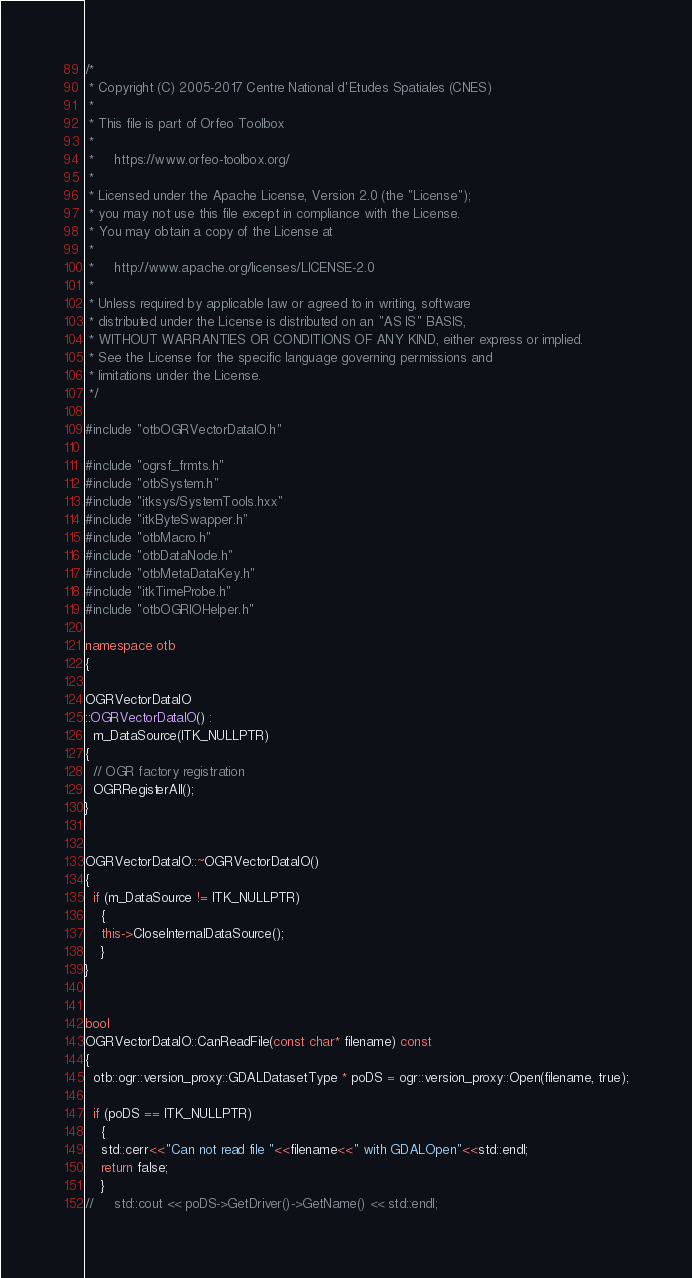Convert code to text. <code><loc_0><loc_0><loc_500><loc_500><_C++_>/*
 * Copyright (C) 2005-2017 Centre National d'Etudes Spatiales (CNES)
 *
 * This file is part of Orfeo Toolbox
 *
 *     https://www.orfeo-toolbox.org/
 *
 * Licensed under the Apache License, Version 2.0 (the "License");
 * you may not use this file except in compliance with the License.
 * You may obtain a copy of the License at
 *
 *     http://www.apache.org/licenses/LICENSE-2.0
 *
 * Unless required by applicable law or agreed to in writing, software
 * distributed under the License is distributed on an "AS IS" BASIS,
 * WITHOUT WARRANTIES OR CONDITIONS OF ANY KIND, either express or implied.
 * See the License for the specific language governing permissions and
 * limitations under the License.
 */

#include "otbOGRVectorDataIO.h"

#include "ogrsf_frmts.h"
#include "otbSystem.h"
#include "itksys/SystemTools.hxx"
#include "itkByteSwapper.h"
#include "otbMacro.h"
#include "otbDataNode.h"
#include "otbMetaDataKey.h"
#include "itkTimeProbe.h"
#include "otbOGRIOHelper.h"

namespace otb
{

OGRVectorDataIO
::OGRVectorDataIO() :
  m_DataSource(ITK_NULLPTR)
{
  // OGR factory registration
  OGRRegisterAll();
}


OGRVectorDataIO::~OGRVectorDataIO()
{
  if (m_DataSource != ITK_NULLPTR)
    {
    this->CloseInternalDataSource();
    }
}


bool
OGRVectorDataIO::CanReadFile(const char* filename) const
{
  otb::ogr::version_proxy::GDALDatasetType * poDS = ogr::version_proxy::Open(filename, true);

  if (poDS == ITK_NULLPTR)
    {
    std::cerr<<"Can not read file "<<filename<<" with GDALOpen"<<std::endl;
    return false;
    }
//     std::cout << poDS->GetDriver()->GetName() << std::endl;</code> 